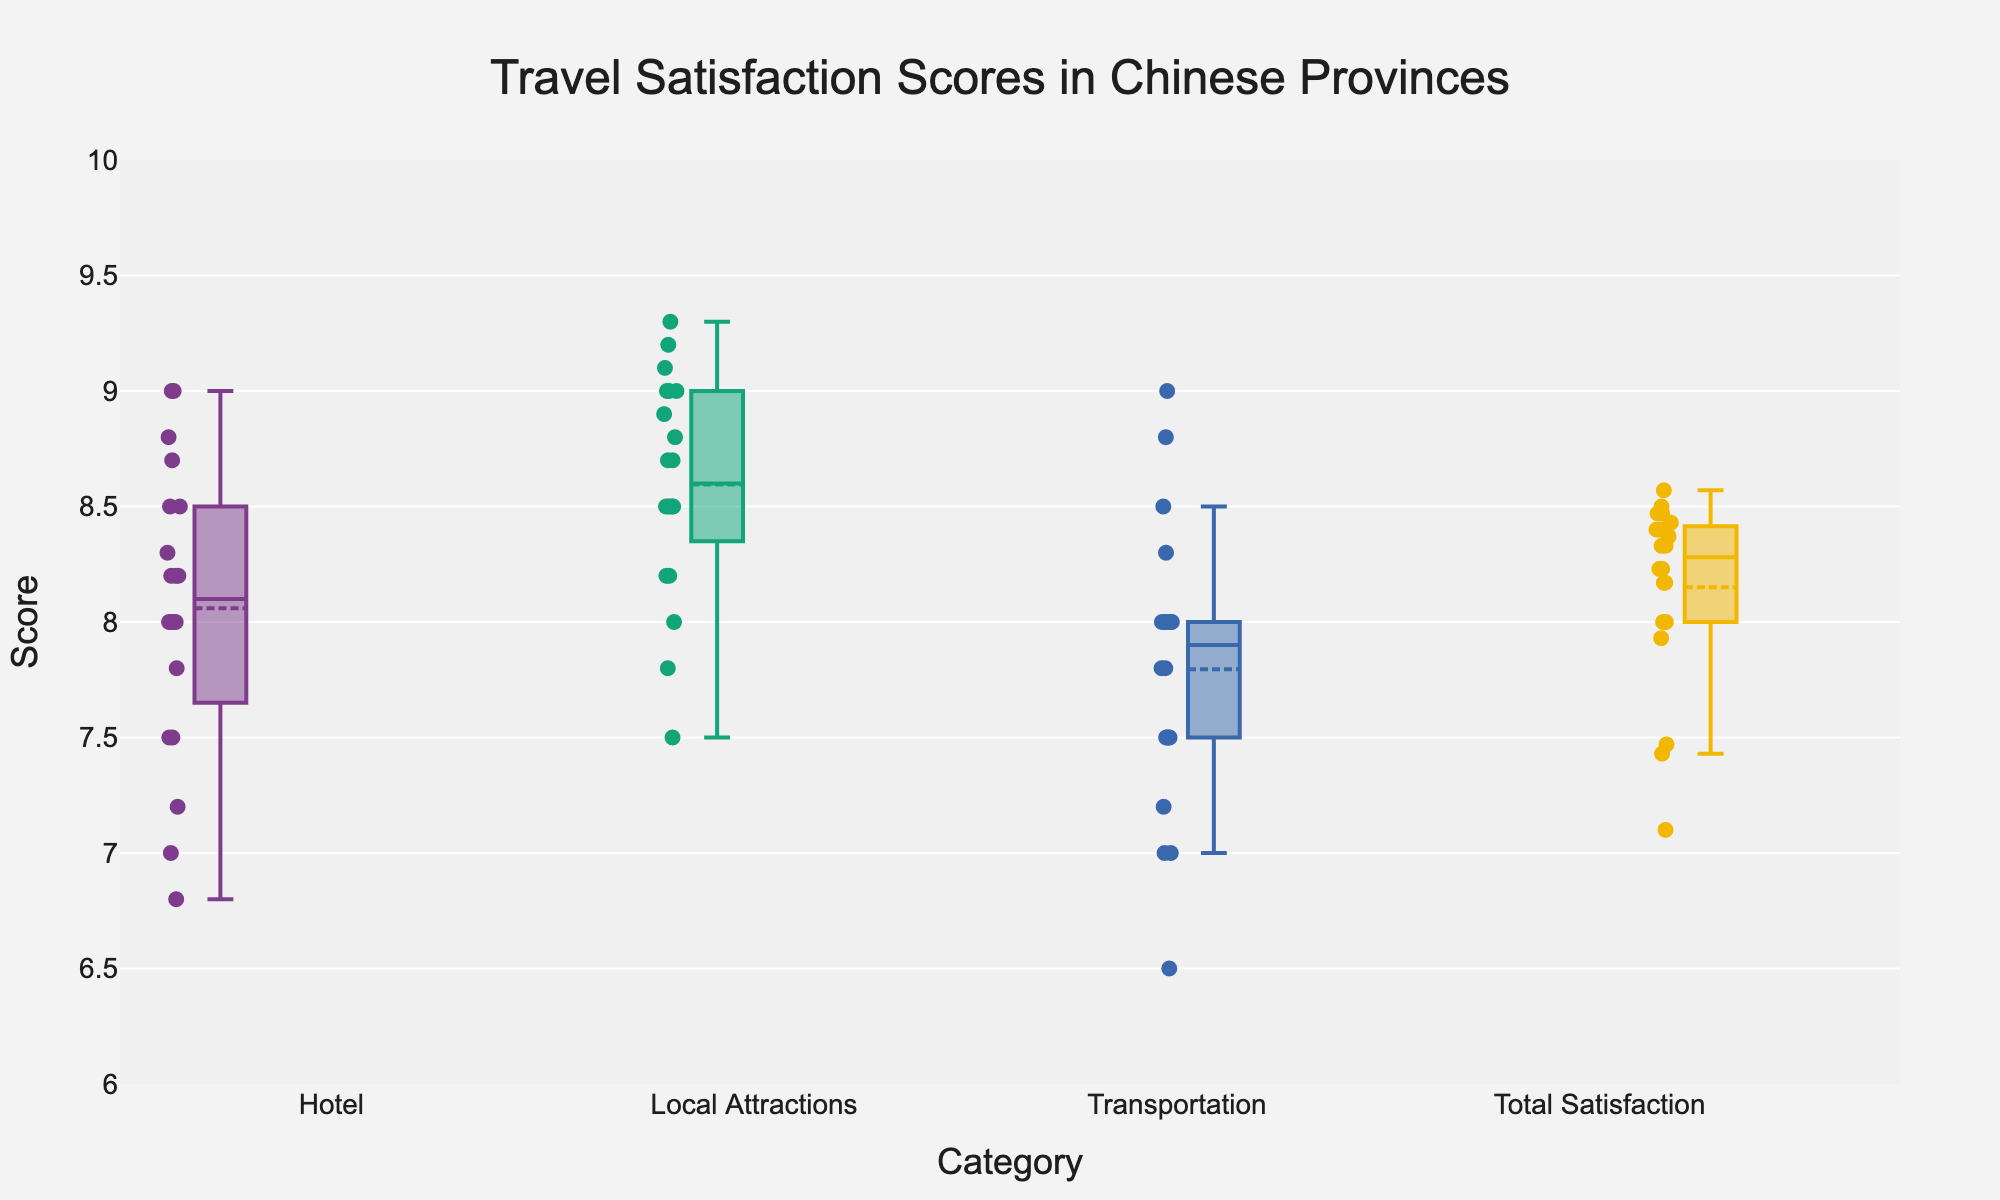What is the title of the plot? The title is usually located at the top of the plot and it is the largest text. It gives a general description of what the plot is about.
Answer: Travel Satisfaction Scores in Chinese Provinces What is the range of the y-axis? The range of the y-axis can be seen from the scale on the axis. The numbers start from the minimum value to the maximum value indicated on the axis.
Answer: 6 to 10 Which category has the highest median satisfaction score? To determine the median satisfaction score for each category, look at the line inside each box plot. The highest median will be the line that is the highest on the y-axis.
Answer: Local Attractions How many categories are plotted? The number of categories can be counted from the x-axis labels. Each unique label corresponds to one category.
Answer: 4 Which category has the widest spread of satisfaction scores? The spread of satisfaction scores can be determined by looking at the length of the box in each box plot. The category with the longest box has the widest spread.
Answer: Local Attractions Are there any outliers in the Total Satisfaction category? Outliers in a box plot are usually represented by individual points that lie outside the whiskers of the box. Check if there are any such points in the Total Satisfaction category.
Answer: No What is the average score for the Hotel category? To find the average, sum all the individual data points in the Hotel category and divide by the number of data points.
Answer: 8.07 Which province has the highest average Total Satisfaction score? Although the plot doesn't directly show provincial averages, we can infer by analyzing individual scatter points for each province within the Total Satisfaction category. Calculate and compare the means across all provinces.
Answer: Beijing Which category has the smallest interquartile range (IQR)? The IQR is the range between the first quartile (bottom of the box) and the third quartile (top of the box). The category with the shortest box width has the smallest IQR.
Answer: Transportation How do Hotel and Local Attractions scores compare in their median values? To compare median values, look at the lines inside the boxes for both the Hotel and Local Attractions categories. Identify which median line is higher.
Answer: Local Attractions has a higher median 